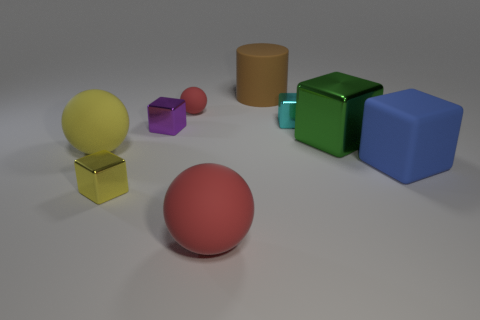Are there fewer tiny metallic blocks behind the small purple metal block than shiny cubes left of the cyan metal block? Upon careful observation of the image, it appears that there are indeed fewer small metallic blocks situated behind the purple block in comparison to the number of shiny cubes to the left of the cyan block. Specifically, the smaller metallic blocks are arranged to create an aesthetically pleasing composition of colors and shapes within the scene. 